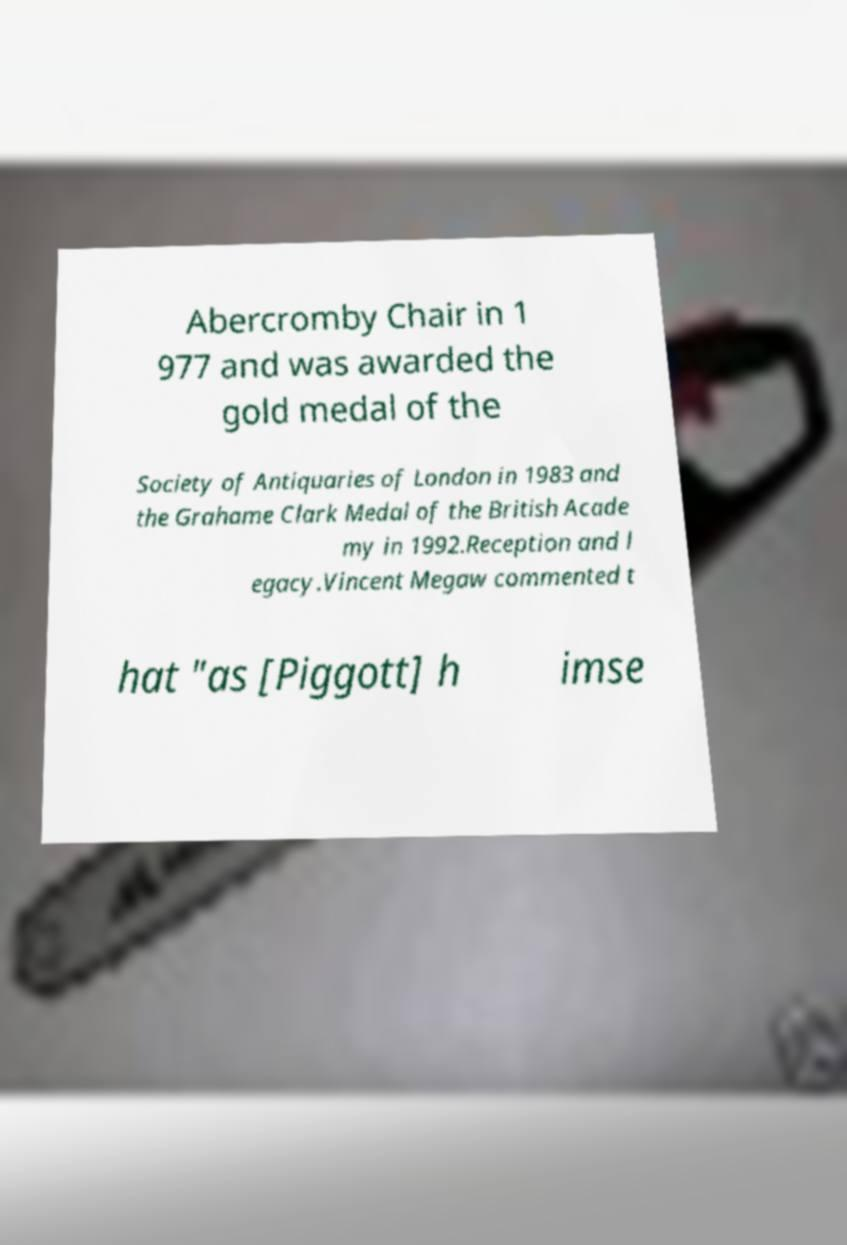Please read and relay the text visible in this image. What does it say? Abercromby Chair in 1 977 and was awarded the gold medal of the Society of Antiquaries of London in 1983 and the Grahame Clark Medal of the British Acade my in 1992.Reception and l egacy.Vincent Megaw commented t hat "as [Piggott] h imse 